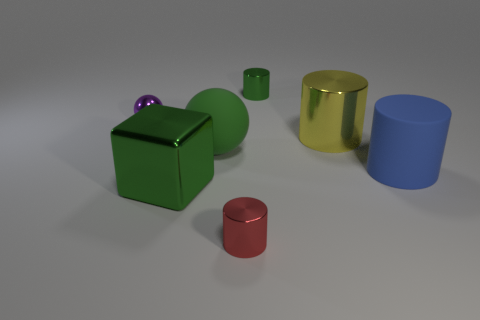There is a green thing that is on the left side of the big green rubber thing; what is its size? The green object on the left side of the larger green cylindrical object appears to be of small size, possibly a small-sized rubber cube or block. 